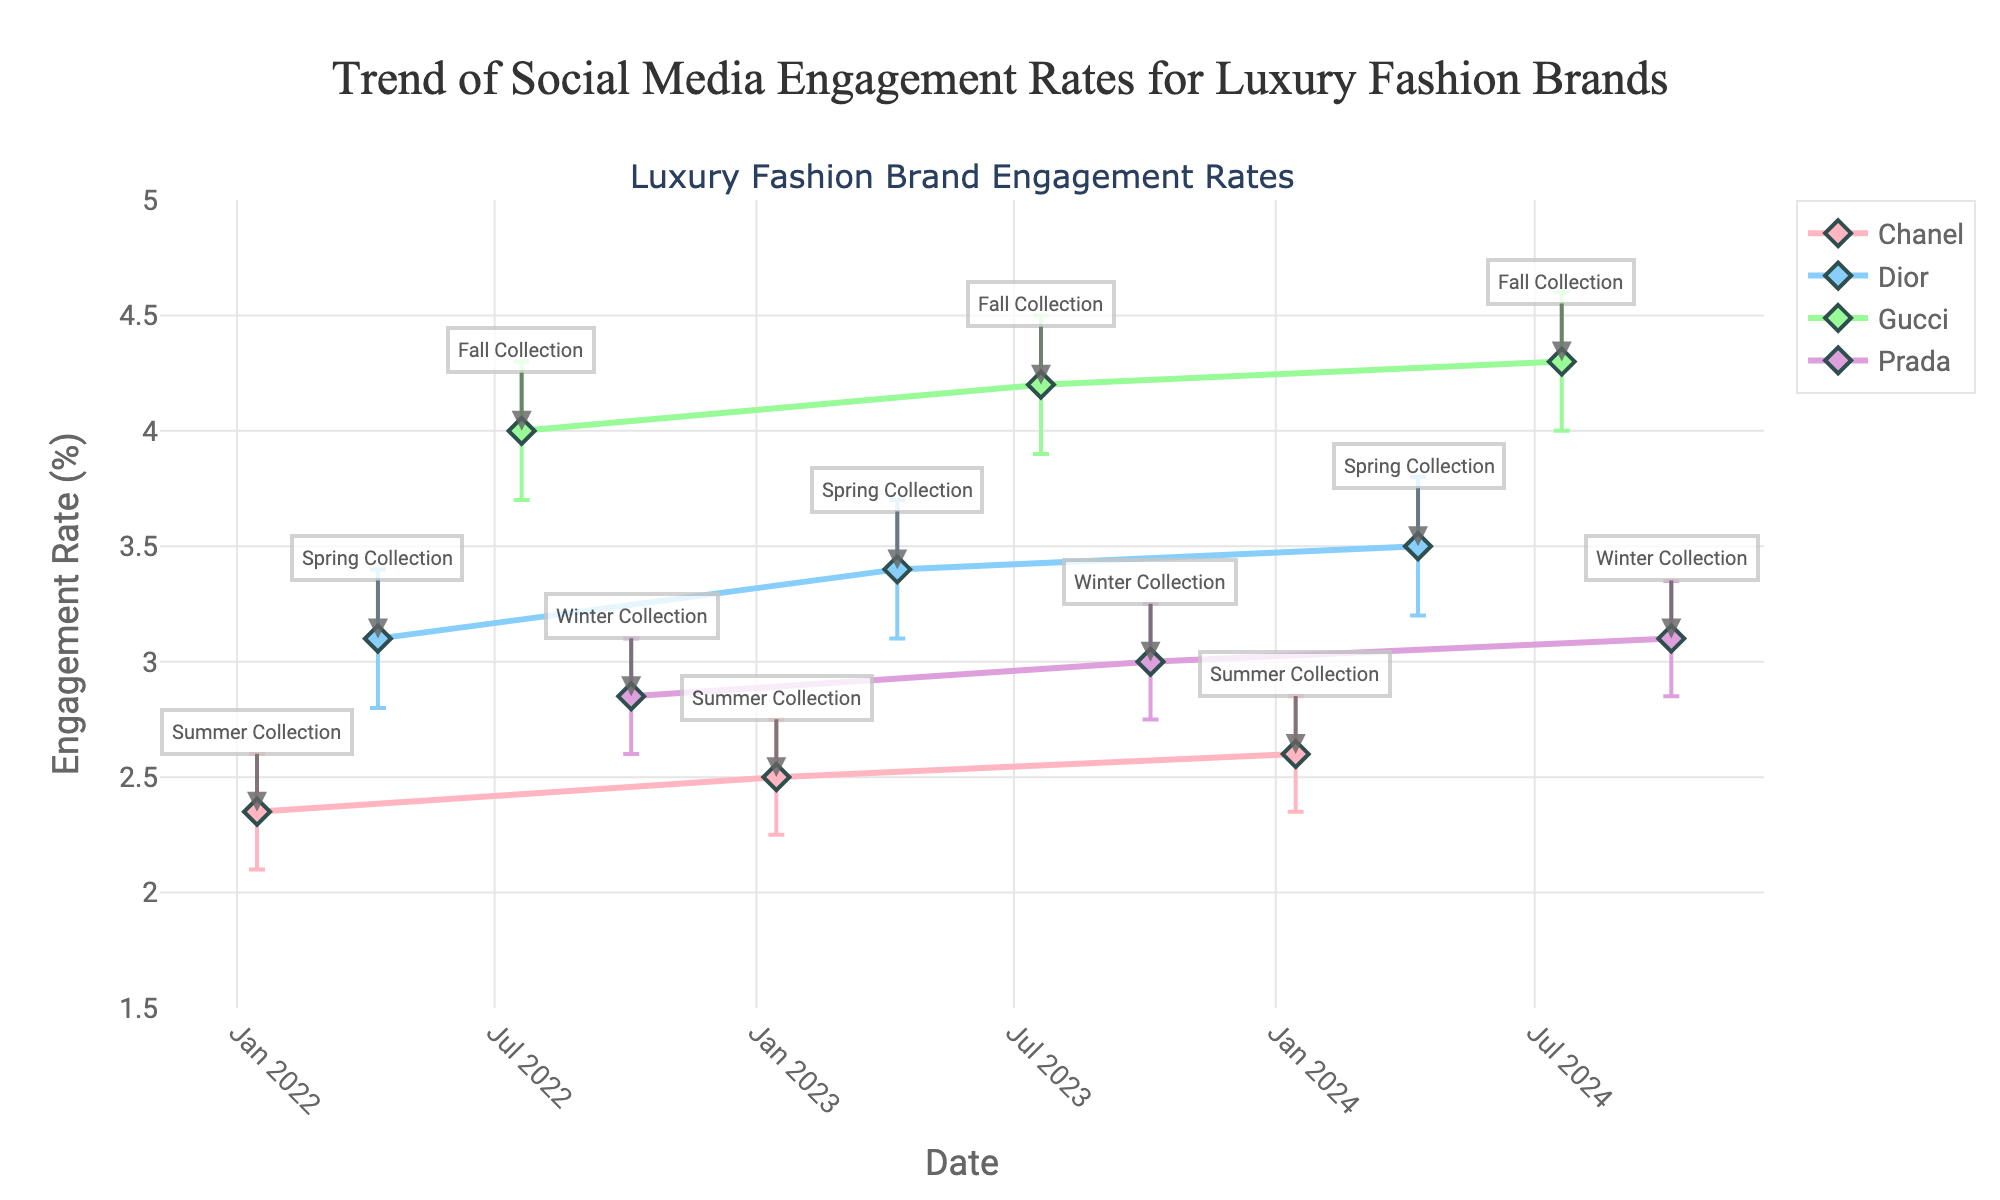What's the engagement rate indicated for Dior's Spring Collection on April 10, 2023? The plot for Dior on April 10, 2023, shows the engagement rate with markers and error bars. Look for the corresponding date on the x-axis and find the engagement rate on the y-axis.
Answer: 3.40 How do the engagement rates for Chanel's Summer Collection change from 2022 to 2024? Check Chanel's data points in January 2022, 2023, and 2024. Compare their engagement rates, connected by lines, to assess the trend.
Answer: They increase from 2.35 to 2.60 Which brand shows the highest engagement rate over the period? Identify the highest point on the y-axis, and check which brand's line reaches that value.
Answer: Gucci Are the confidence intervals for Chanel's Summer Collection in 2023 and 2024 overlapping? Look at the error bars for Chanel in 2023 and 2024. If they overlap, the ranges between upper and lower confidence intervals intersect.
Answer: Yes How does the engagement rate trend for Prada's Winter Collection from 2022 to 2024? Trace Prada's data points for Winter Collection in 2022, 2023, and 2024; observe the change in engagement rate over the years.
Answer: It increases from 2.85 in 2022 to 3.10 in 2024 Which brand shows the greatest increase in engagement rate from their earliest point to their latest? Calculate the difference between the earliest and latest engagement rates for each brand, then determine which has the highest increase. Gucci shows the greatest increase from 4.00 to 4.30.
Answer: Gucci Are any brands' engagement rates within the same confidence interval overlap in 2024? Compare the error bars for all brands in 2024. If any error bars intersect, their confidence intervals overlap.
Answer: Yes What's the average engagement rate for Gucci across all collection releases? Sum Gucci's engagement rates and divide by the number of points (3.70+4.20+4.30) / 3.
Answer: 4.17 Comparing Dior and Prada, which has a more stable engagement rate over time, considering error bars? Look at the width of the error bars for Dior and Prada over the period. The brand with narrower error bars shows less variance and thus greater stability.
Answer: Dior 